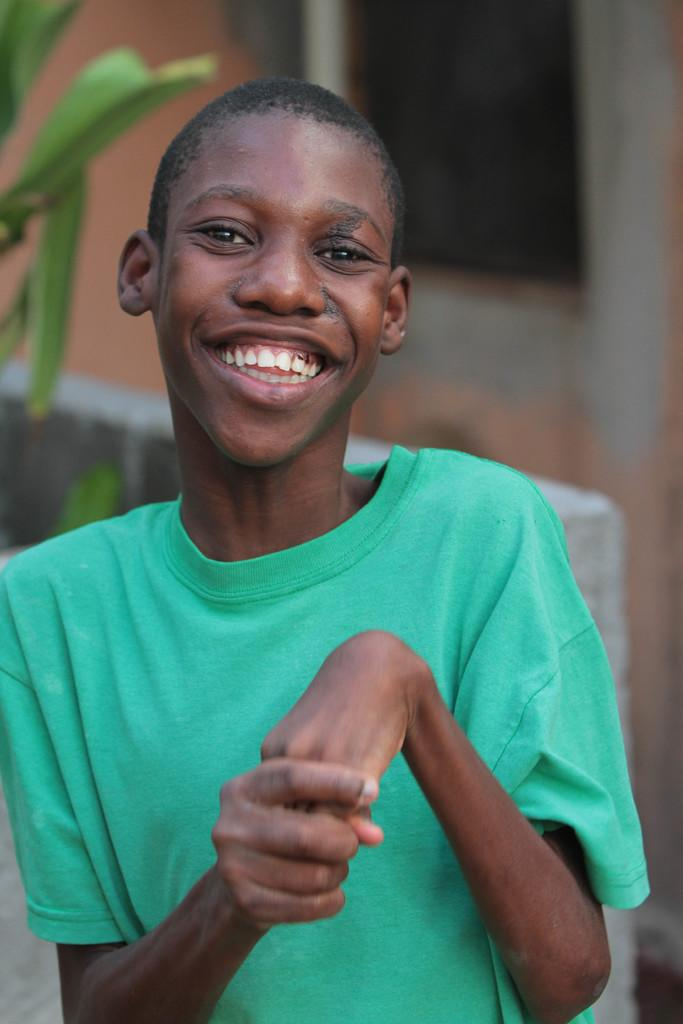Who is the main subject in the image? There is a boy in the image. What can be seen in the background of the image? There are leaves in the background of the image. How would you describe the background of the image? The background of the image is blurry. What type of structure is present in the image? There is a wall in the image. How many boats are visible in the image? There are no boats present in the image. What type of house can be seen in the background of the image? There is no house visible in the image; only a wall and leaves are present in the background. 